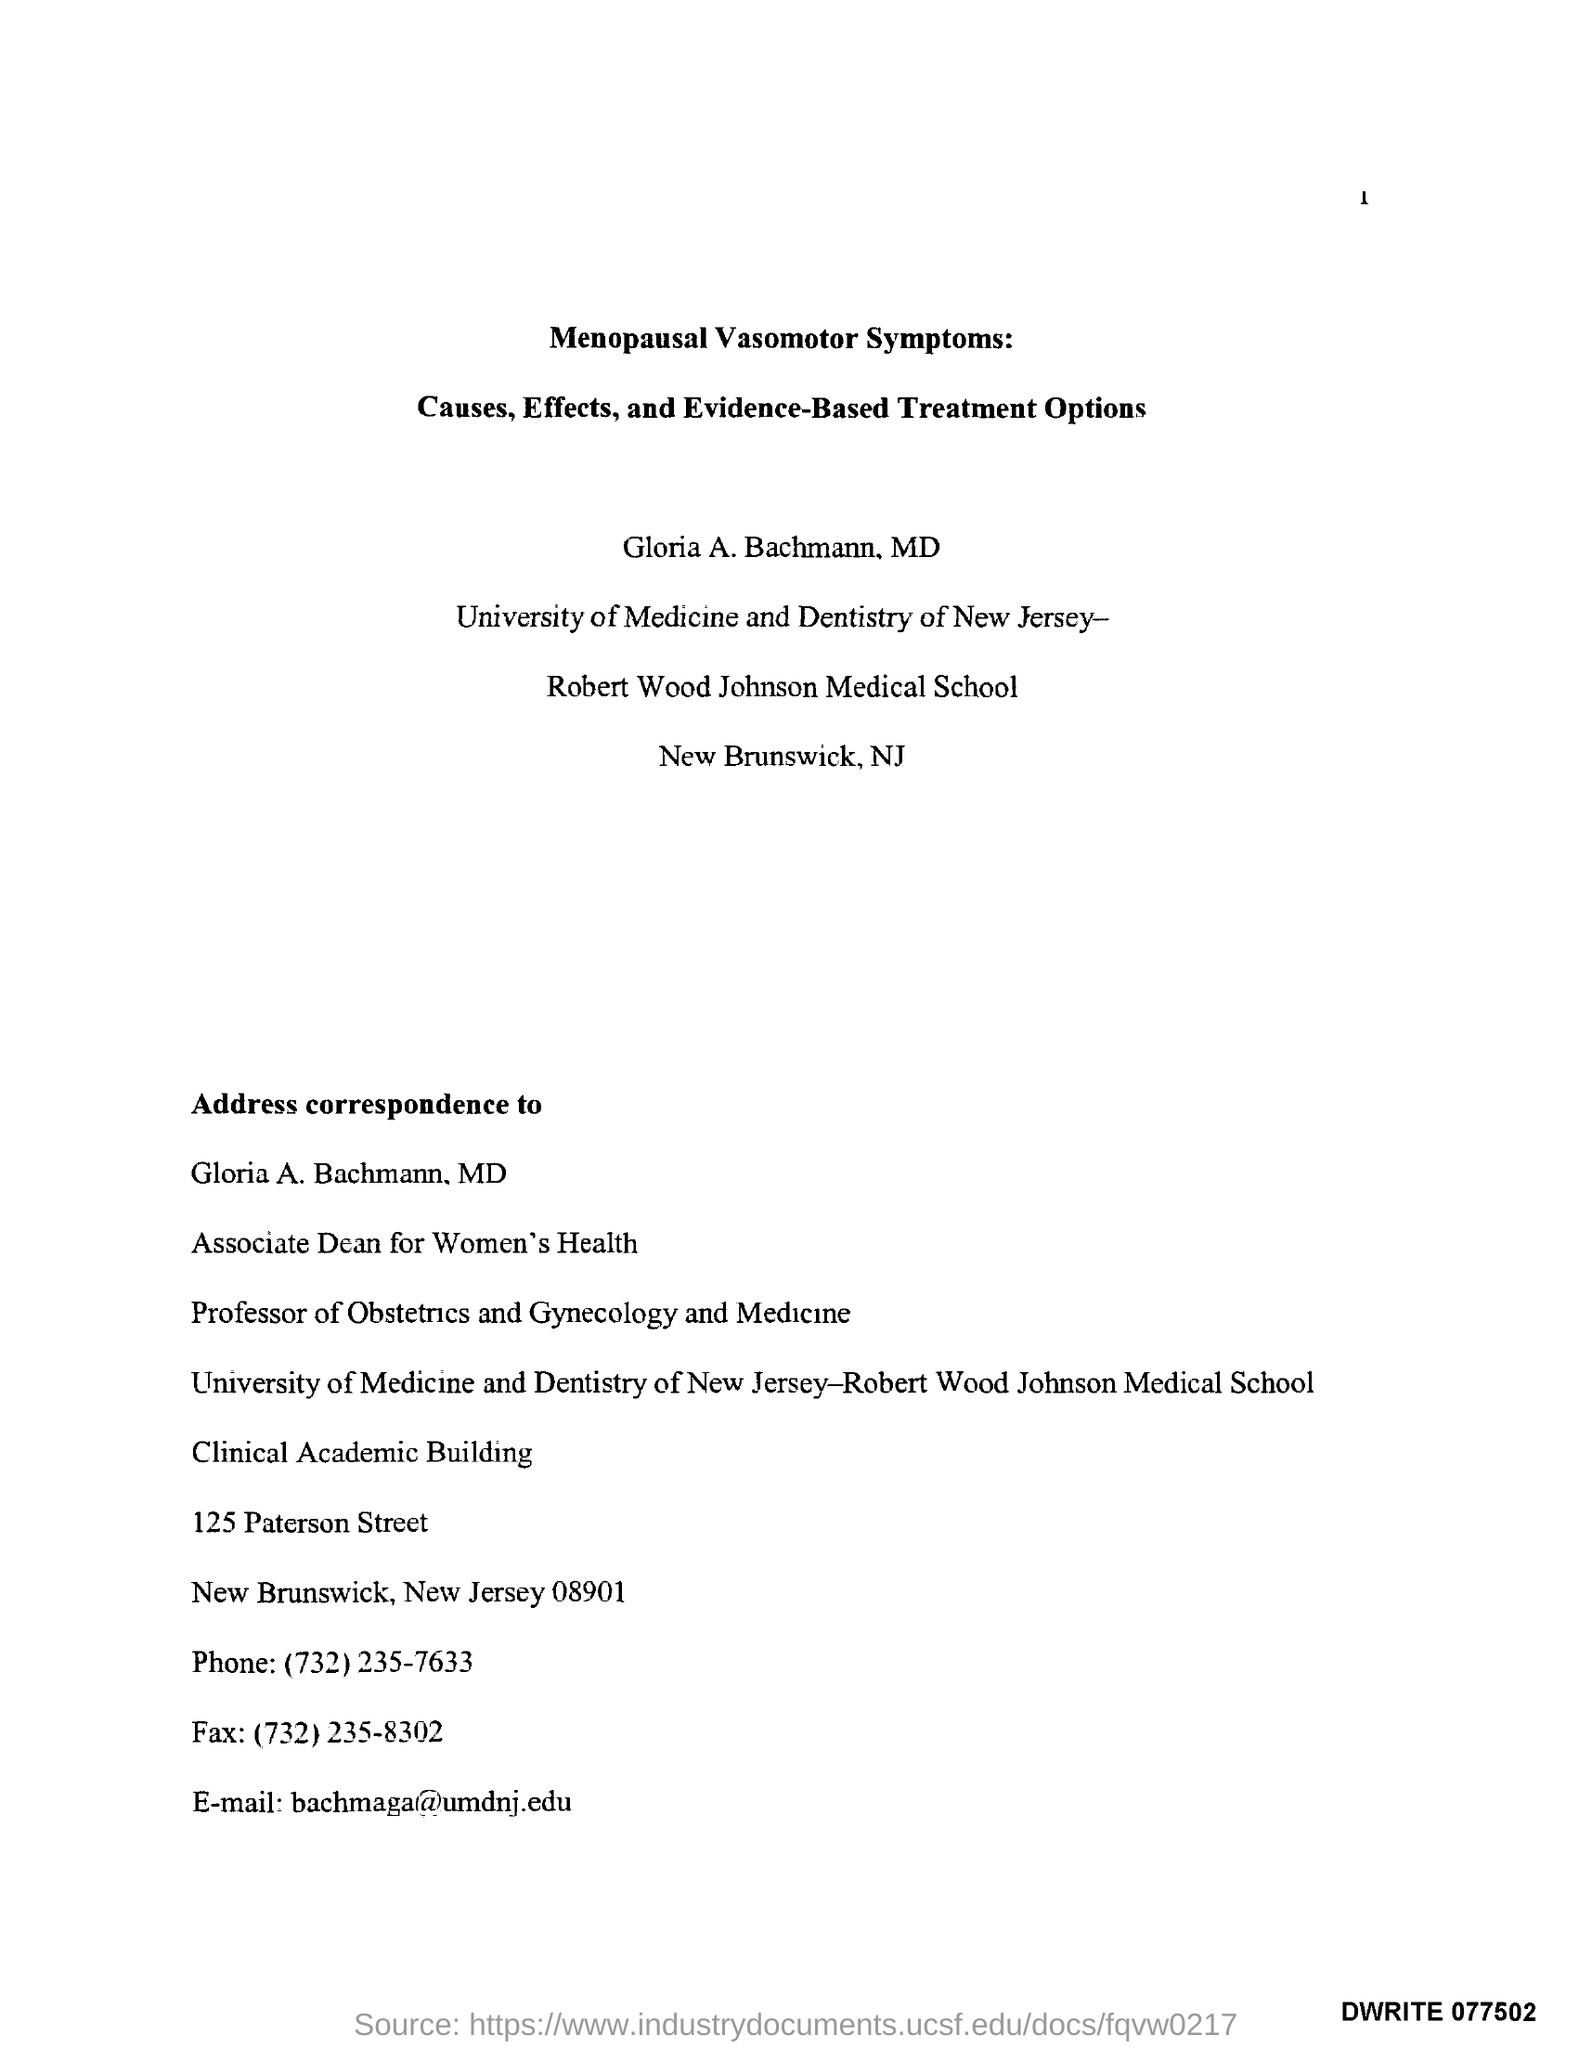Point out several critical features in this image. The University of Medicine and Dentistry of New Jersey is the name of the university. The name of the medical school is Robert Wood Johnson Medical School. The phone number mentioned is (732)235-7633. The Clinical Academic Building is the address for correspondence related to the building. I am inquiring about the telephone number (732)235-8302. 